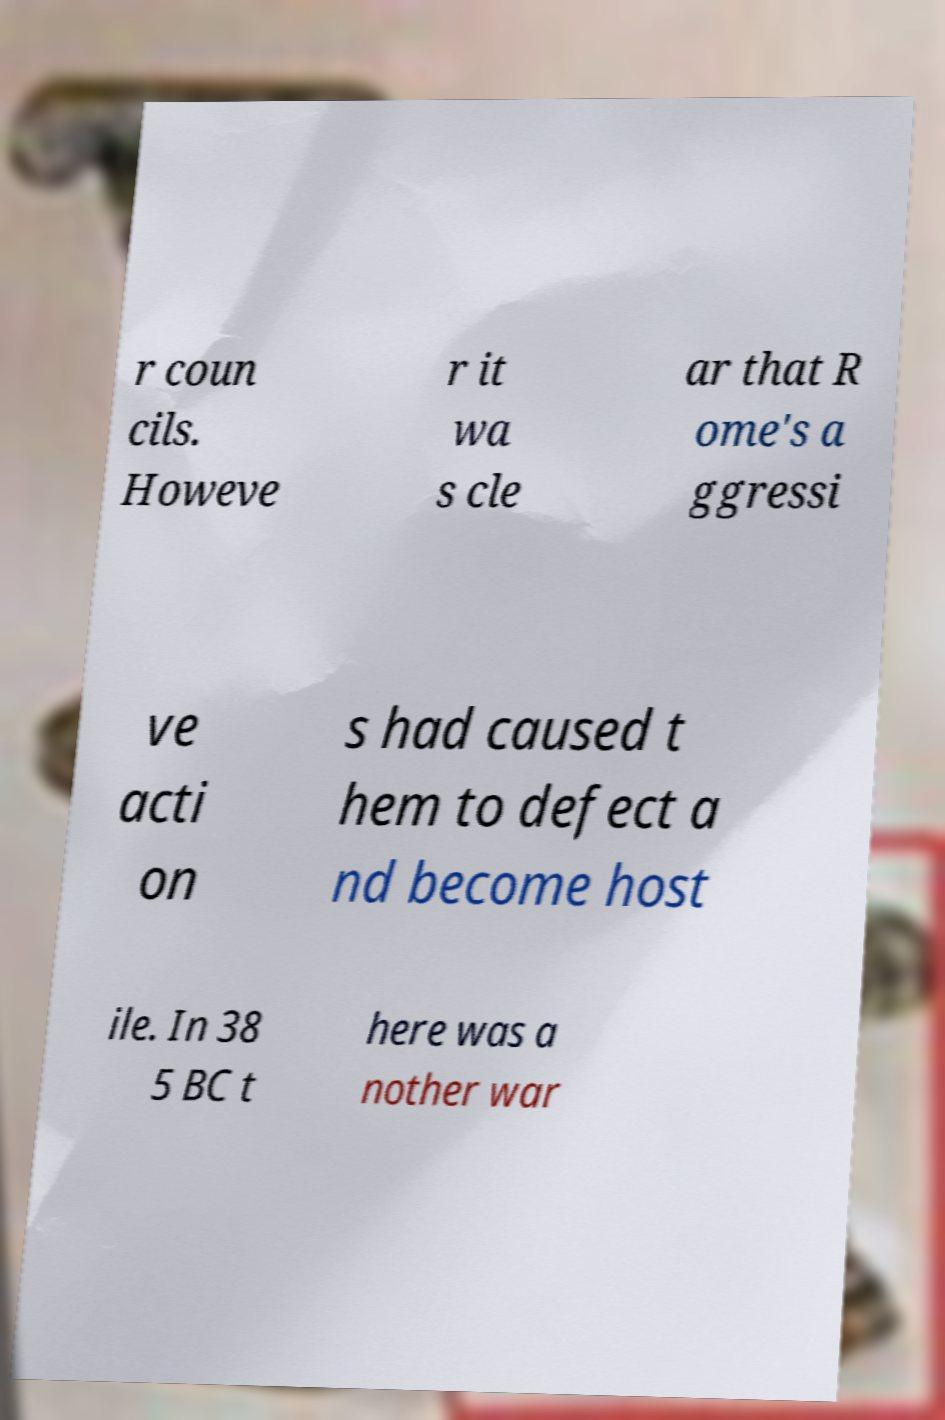Could you extract and type out the text from this image? r coun cils. Howeve r it wa s cle ar that R ome's a ggressi ve acti on s had caused t hem to defect a nd become host ile. In 38 5 BC t here was a nother war 